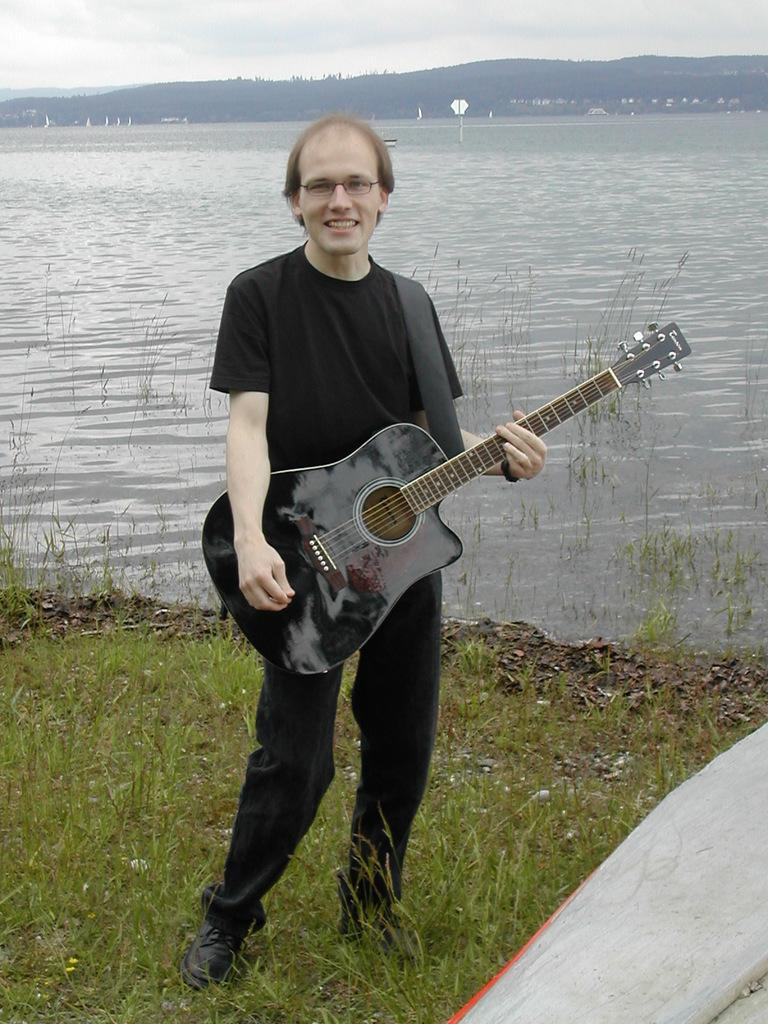What is the main subject of the image? There is a man in the image. What is the man doing in the image? The man is standing on the ground. What object is the man holding in the image? The man is holding a guitar in his hand. What accessory is the man wearing in the image? The man is wearing spectacles. What can be seen in the background of the image? There is water and hills visible in the background of the image. What type of underwear is the man wearing in the image? There is no information about the man's underwear in the image, so it cannot be determined. Does the existence of the man in the image prove the existence of extraterrestrial life? The presence of the man in the image does not prove the existence of extraterrestrial life, as it only shows a man holding a guitar. 